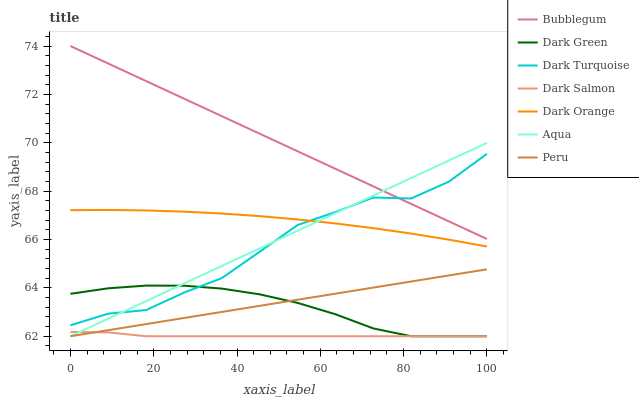Does Dark Salmon have the minimum area under the curve?
Answer yes or no. Yes. Does Bubblegum have the maximum area under the curve?
Answer yes or no. Yes. Does Dark Turquoise have the minimum area under the curve?
Answer yes or no. No. Does Dark Turquoise have the maximum area under the curve?
Answer yes or no. No. Is Peru the smoothest?
Answer yes or no. Yes. Is Dark Turquoise the roughest?
Answer yes or no. Yes. Is Aqua the smoothest?
Answer yes or no. No. Is Aqua the roughest?
Answer yes or no. No. Does Aqua have the lowest value?
Answer yes or no. Yes. Does Dark Turquoise have the lowest value?
Answer yes or no. No. Does Bubblegum have the highest value?
Answer yes or no. Yes. Does Dark Turquoise have the highest value?
Answer yes or no. No. Is Dark Salmon less than Dark Orange?
Answer yes or no. Yes. Is Bubblegum greater than Dark Green?
Answer yes or no. Yes. Does Peru intersect Dark Salmon?
Answer yes or no. Yes. Is Peru less than Dark Salmon?
Answer yes or no. No. Is Peru greater than Dark Salmon?
Answer yes or no. No. Does Dark Salmon intersect Dark Orange?
Answer yes or no. No. 